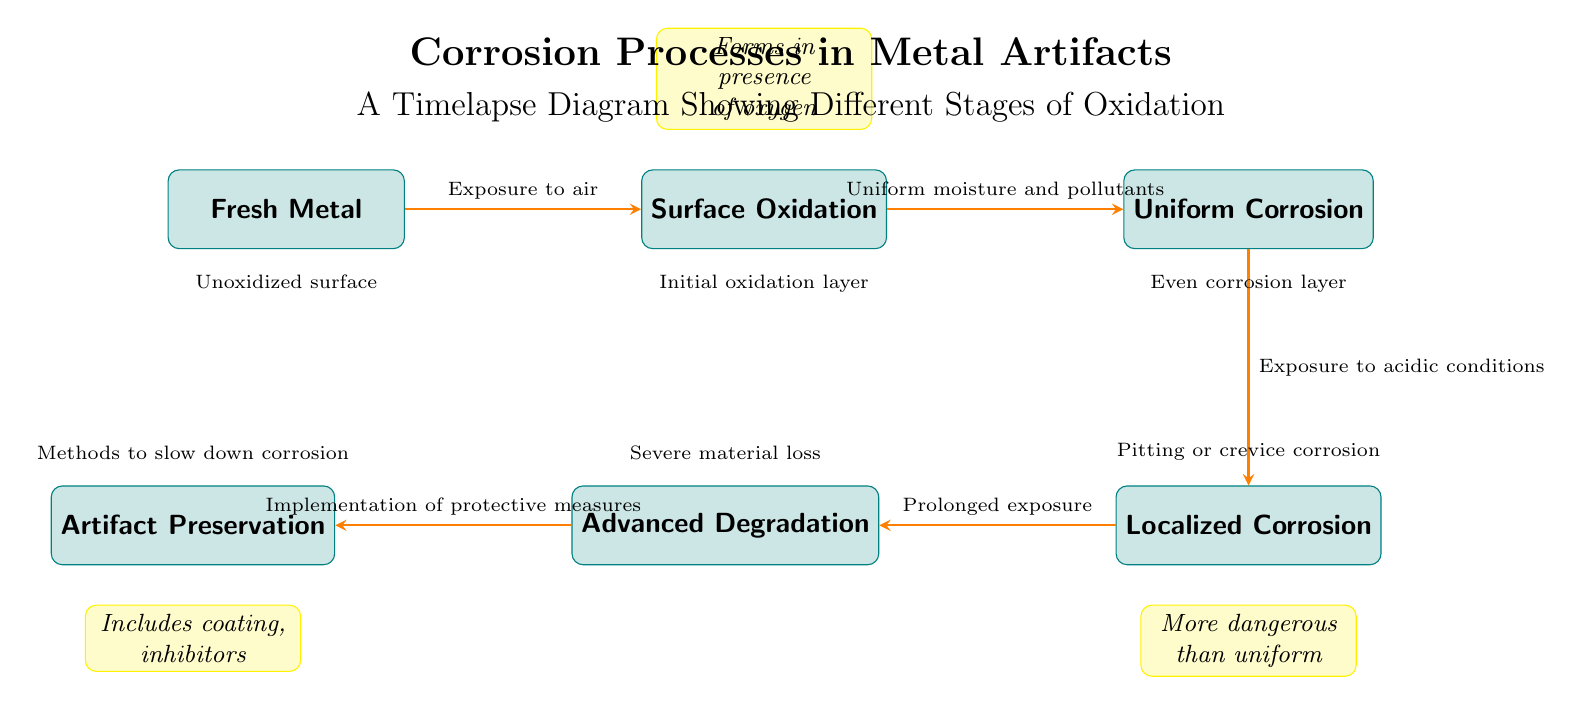What is the first stage in the corrosion process? The diagram indicates that "Fresh Metal" is the starting point of the corrosion process before any oxidation occurs.
Answer: Fresh Metal How many main processes are shown in the diagram? A count of the distinct nodes representing different stages reveals there are six main processes illustrated: Fresh Metal, Surface Oxidation, Uniform Corrosion, Localized Corrosion, Advanced Degradation, and Artifact Preservation.
Answer: 6 What causes the transition from Surface Oxidation to Uniform Corrosion? The diagram specifies that the transition occurs due to "Uniform moisture and pollutants," indicating these environmental factors lead to further corrosion after initial oxidation.
Answer: Uniform moisture and pollutants Which type of corrosion is described as more dangerous than uniform? The diagram highlights "Localized Corrosion" as being more dangerous than the "Uniform Corrosion" stage, suggesting that it poses a greater risk to the integrity of metal artifacts.
Answer: Localized Corrosion What does the "Advanced Degradation" box represent? This box symbolizes a later stage of corrosion where severe material loss occurs, indicating significant deterioration of the artifact's structure after prolonged exposure to corrosive conditions.
Answer: Severe material loss What protective measures can be implemented after "Advanced Degradation"? The diagram describes that "Implementation of protective measures" leads to the "Artifact Preservation" stage, indicating that specific actions can still help preserve the metal artifact even after deterioration has begun.
Answer: Implementation of protective measures What is the relationship between Surface Oxidation and Fresh Metal? The arrow from "Fresh Metal" to "Surface Oxidation" indicates that exposure to air initiates the oxidation process, marking the first significant step in the corrosion timeline.
Answer: Exposure to air What kind of corrosion involves pitting or crevice corrosion? Localized Corrosion is characterized by phenomena such as pitting or crevice corrosion, which means this type specifically refers to irregular corrosion that can create small pits on the metal surface.
Answer: Localized Corrosion What is included in the "Artifact Preservation" process? The box labeled "Artifact Preservation" suggests that it encompasses methods to slow down corrosion, including possible coating methods or chemical inhibitors.
Answer: Methods to slow down corrosion 